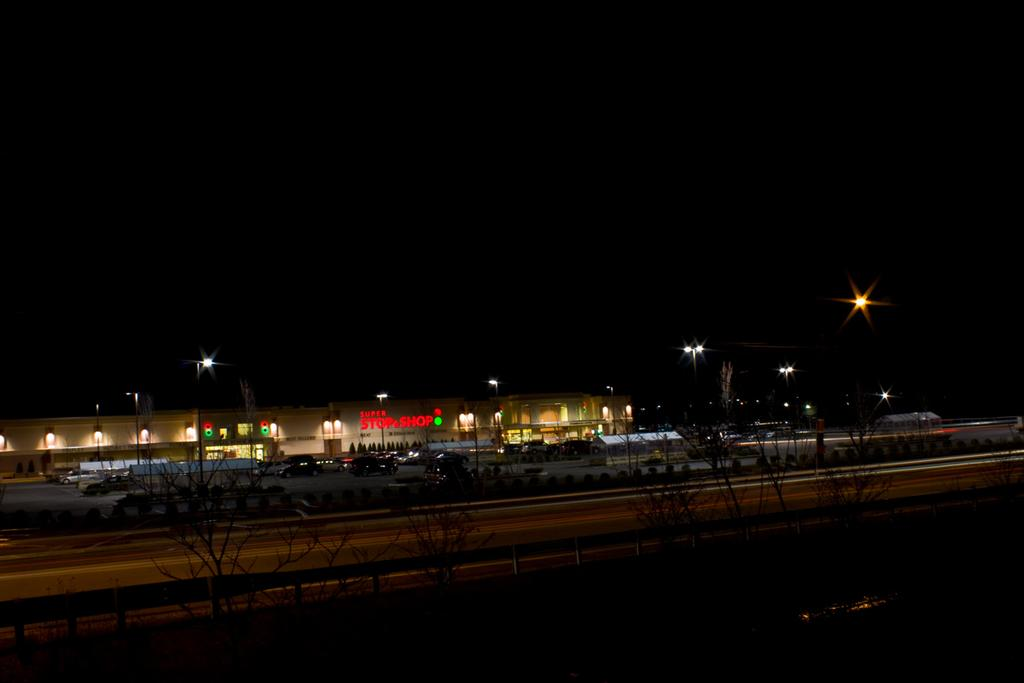What type of structure is visible in the image? There is a building in the image. What natural elements can be seen in the image? There are trees in the image. What man-made objects are present in the image? There are vehicles parked and pole lights in the image. What temporary structures are visible in the image? There are tents in the image. Can you tell me how much blood is visible in the image? There is no blood visible in the image. What type of vessel is being used by the people in the image? There are no vessels present in the image. 